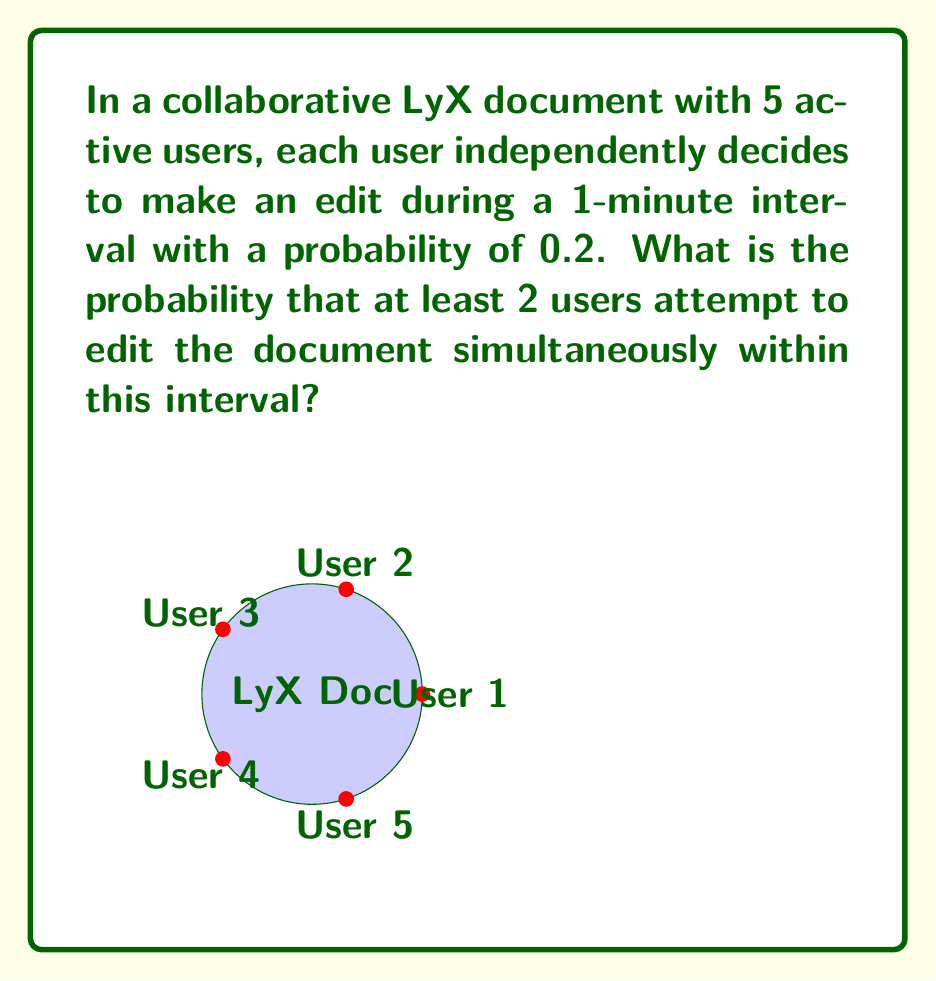Provide a solution to this math problem. Let's approach this step-by-step:

1) First, we need to find the probability of at least 2 users editing simultaneously. This is equivalent to 1 minus the probability of 0 or 1 user editing.

2) The probability of a user not editing is $1 - 0.2 = 0.8$

3) We can use the binomial distribution to solve this:

   Let $X$ be the number of users editing simultaneously.
   
   $P(X = k) = \binom{n}{k} p^k (1-p)^{n-k}$

   Where $n = 5$ (total users), $p = 0.2$ (probability of editing)

4) Probability of 0 users editing:
   $P(X = 0) = \binom{5}{0} 0.2^0 0.8^5 = 0.8^5 = 0.32768$

5) Probability of 1 user editing:
   $P(X = 1) = \binom{5}{1} 0.2^1 0.8^4 = 5 \cdot 0.2 \cdot 0.8^4 = 0.4096$

6) Probability of 0 or 1 user editing:
   $P(X \leq 1) = P(X = 0) + P(X = 1) = 0.32768 + 0.4096 = 0.73728$

7) Therefore, the probability of at least 2 users editing simultaneously:
   $P(X \geq 2) = 1 - P(X \leq 1) = 1 - 0.73728 = 0.26272$
Answer: $0.26272$ or approximately $26.27\%$ 